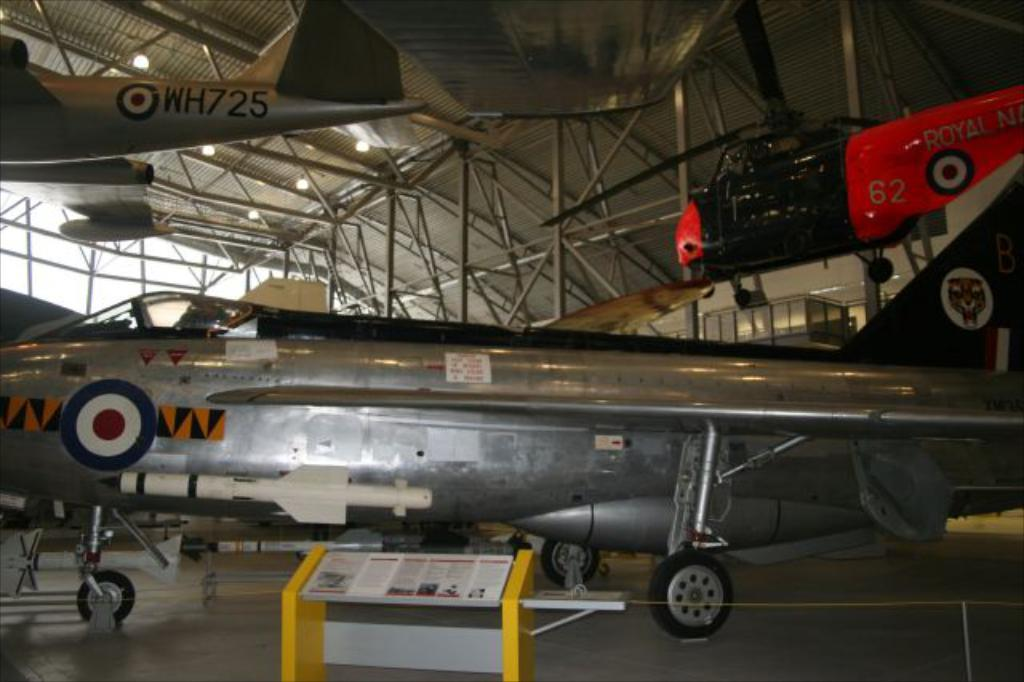<image>
Render a clear and concise summary of the photo. A Royal Navy helicopter is suspended from the ceiling. 